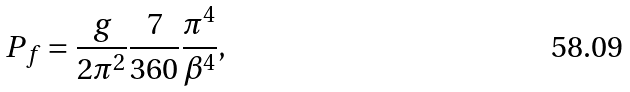<formula> <loc_0><loc_0><loc_500><loc_500>P _ { f } = \frac { g } { 2 \pi ^ { 2 } } \frac { 7 } { 3 6 0 } \frac { \pi ^ { 4 } } { \beta ^ { 4 } } ,</formula> 